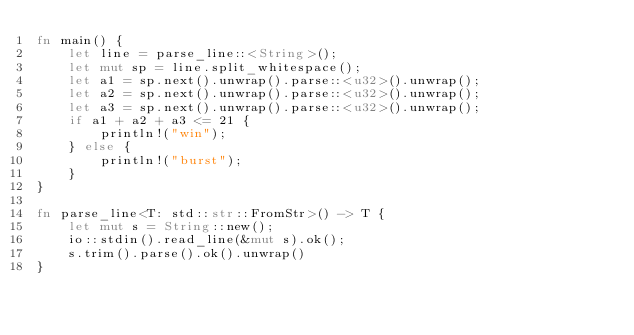<code> <loc_0><loc_0><loc_500><loc_500><_Rust_>fn main() {
    let line = parse_line::<String>();
    let mut sp = line.split_whitespace();
    let a1 = sp.next().unwrap().parse::<u32>().unwrap();
    let a2 = sp.next().unwrap().parse::<u32>().unwrap();
    let a3 = sp.next().unwrap().parse::<u32>().unwrap();
    if a1 + a2 + a3 <= 21 {
        println!("win");
    } else {
        println!("burst");
    }
}

fn parse_line<T: std::str::FromStr>() -> T {
    let mut s = String::new();
    io::stdin().read_line(&mut s).ok();
    s.trim().parse().ok().unwrap()
}
</code> 